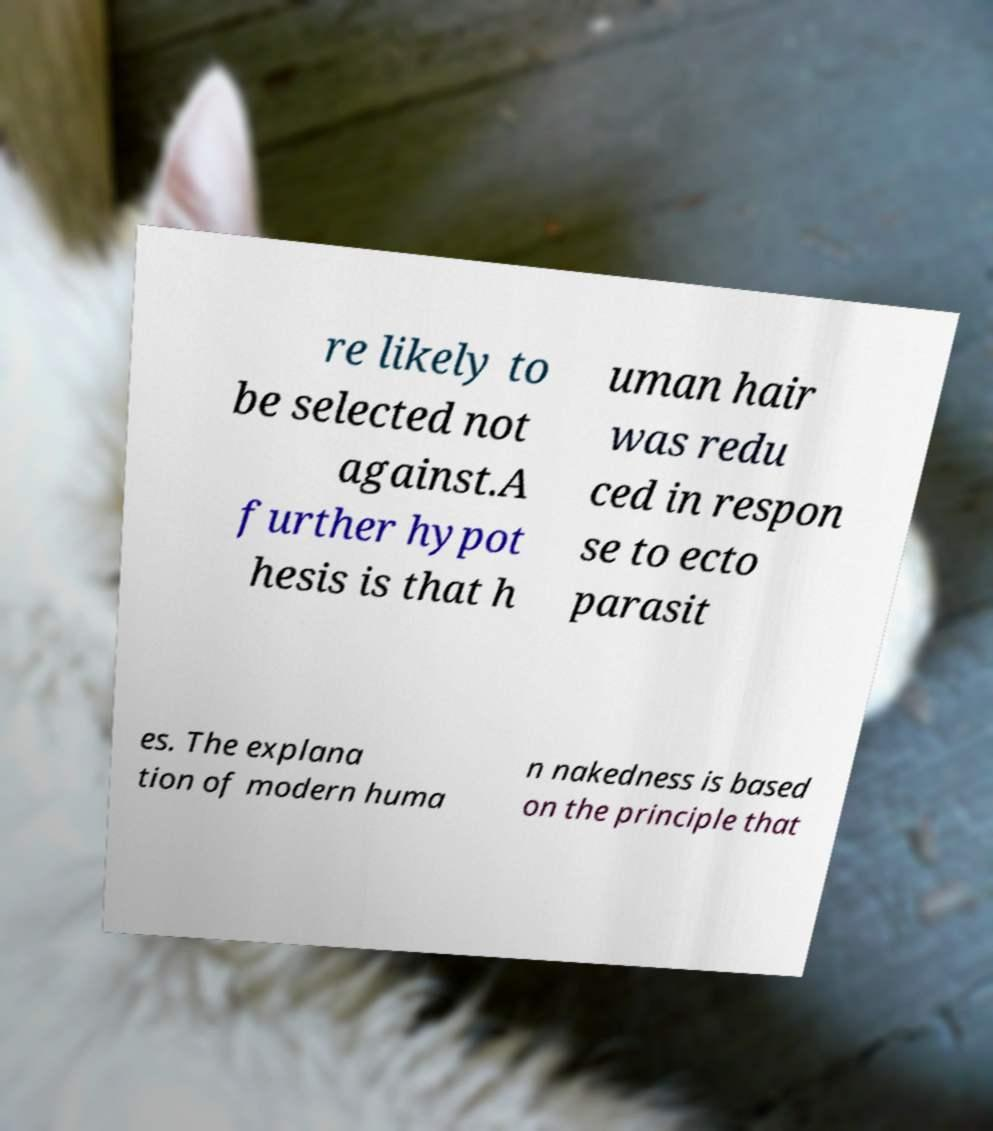What messages or text are displayed in this image? I need them in a readable, typed format. re likely to be selected not against.A further hypot hesis is that h uman hair was redu ced in respon se to ecto parasit es. The explana tion of modern huma n nakedness is based on the principle that 